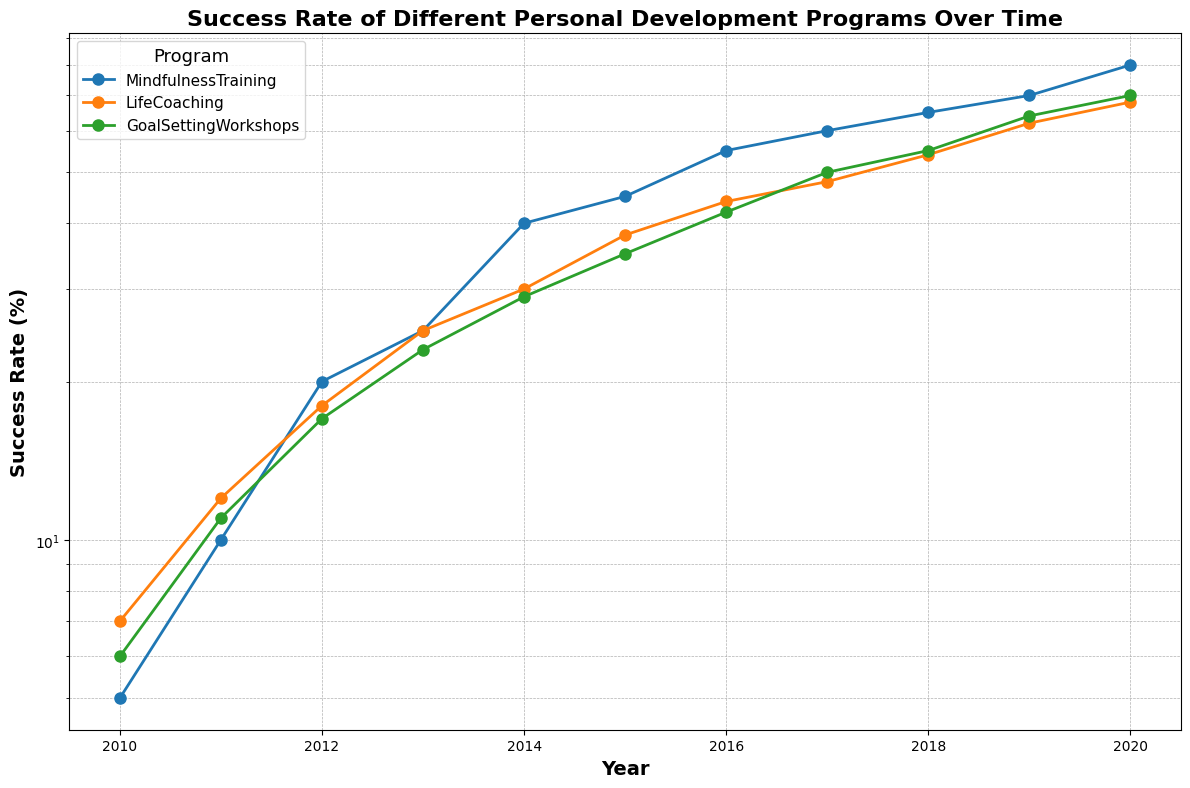What is the success rate of Mindfulness Training in 2015? The success rate of Mindfulness Training in 2015 can be read directly from the plot. Locate the line representing Mindfulness Training and find the value at the year 2015 on the x-axis.
Answer: 45 Which program had the highest success rate in 2020? To find the program with the highest success rate in 2020, compare the values of the three lines at the year 2020. The line that reaches the highest point indicates the highest success rate.
Answer: Mindfulness Training How much did the success rate of Life Coaching increase from 2010 to 2020? To determine the increase, subtract the success rate of Life Coaching in 2010 from that in 2020. The values can be read directly from the plot at the corresponding years.
Answer: 61 Between 2015 and 2020, which program saw the greatest improvement in success rate? Calculate the difference in success rates for each program between 2015 and 2020. Compare these differences and identify the program with the largest increase.
Answer: Mindfulness Training Which year did Goal Setting Workshops surpass a 50% success rate? Identify the point on the Goal Setting Workshops line where it crosses the 50% mark. Read the corresponding year on the x-axis.
Answer: 2017 By how many percentage points did the success rate of Goal Setting Workshops grow between 2014 and 2017? Subtract the success rate of Goal Setting Workshops in 2014 from that in 2017.
Answer: 21 What is the average success rate of Mindfulness Training between 2010 and 2020? Sum the success rates of Mindfulness Training for each year from 2010 to 2020, then divide by the total number of years (11).
Answer: 46 Which program had the smallest success rate growth between 2010 and 2020? Calculate the difference in success rates for each program between 2010 and 2020 and identify the one with the smallest increase.
Answer: Life Coaching What is the success rate difference between Mindfulness Training and Life Coaching in 2020? Subtract the success rate of Life Coaching in 2020 from that of Mindfulness Training in the same year.
Answer: 12 